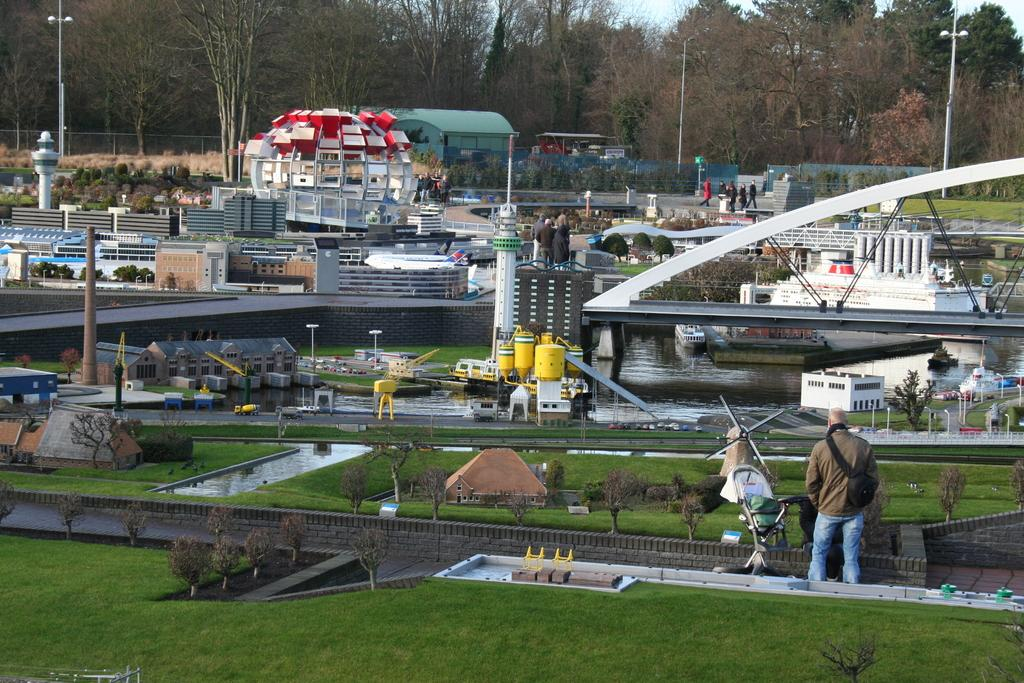What type of terrain is visible in the image? There is grass in the image. What natural element is present in the image? There is water in the image. What man-made structure can be seen in the image? There is a bridge in the image. What part of the natural environment is visible in the image? The sky is visible at the top of the image. What type of structures are present in the image? There are buildings in the image. What other types of vegetation are present in the image? There are plants and trees in the image. What living beings are present in the image? There are people in the image. What type of transportation is visible in the image? There are boats in the image. How many cameras are visible in the image? There are no cameras present in the image. What type of feast is being prepared in the image? There is no feast being prepared in the image. 